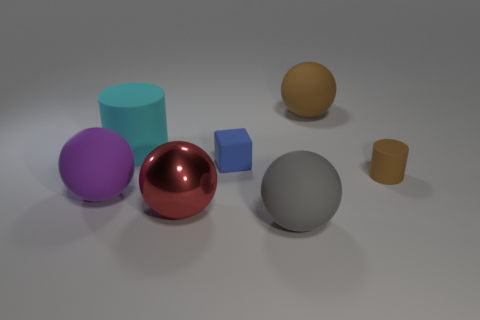How many objects are there, and can you describe their colors? There are six objects in the image, each with a distinct color. From left to right: a large purple cylinder, a large red sphere with a reflective surface, a gray sphere with a matte finish, a small blue cube, a small yellow sphere, and a small brown cylinder. 